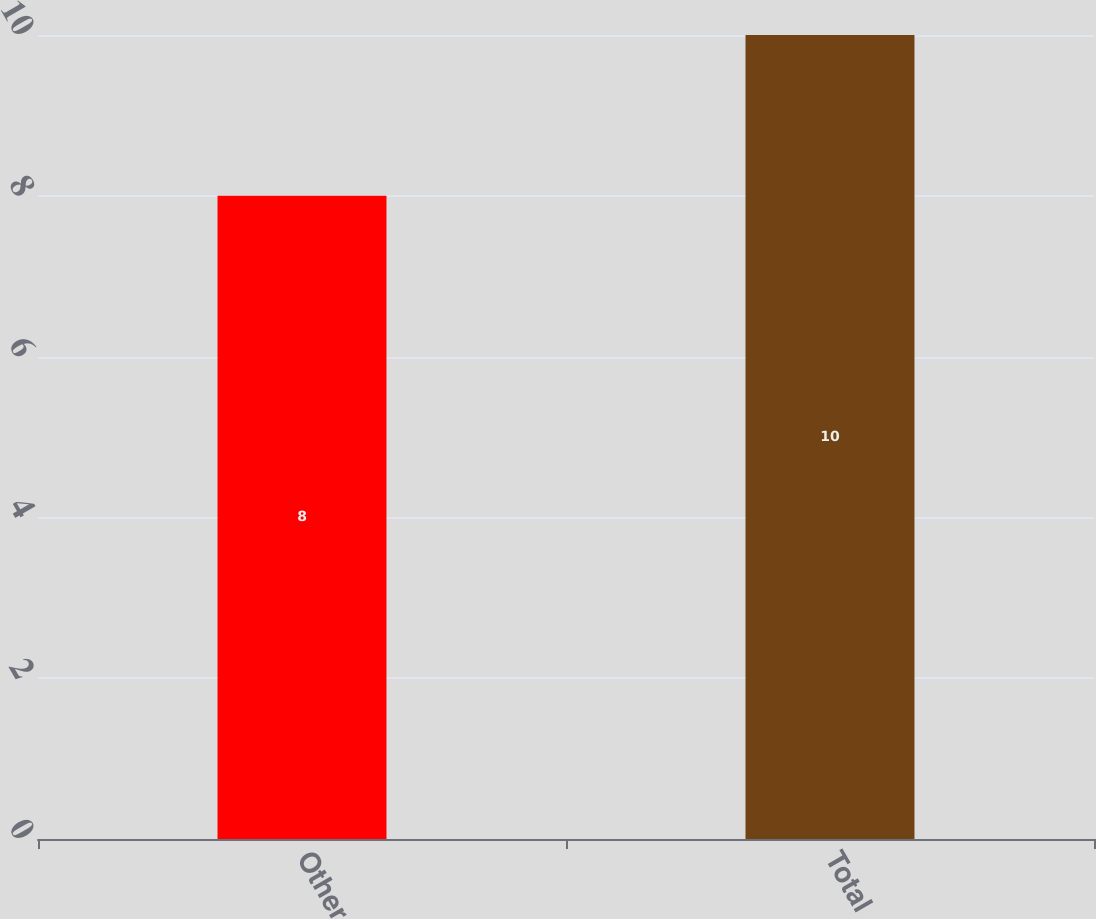Convert chart. <chart><loc_0><loc_0><loc_500><loc_500><bar_chart><fcel>Other<fcel>Total<nl><fcel>8<fcel>10<nl></chart> 